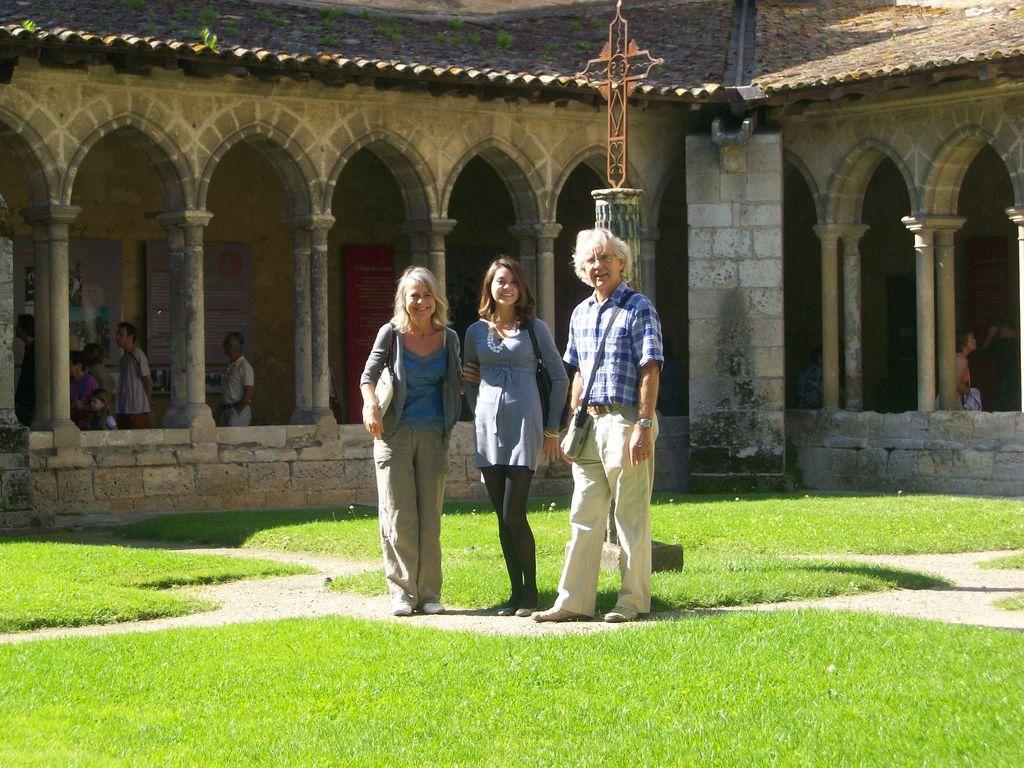In one or two sentences, can you explain what this image depicts? In this image there are three people standing and posing for the camera with a smile on their face, there is grass on the surface, behind them there are a few people in a house. 